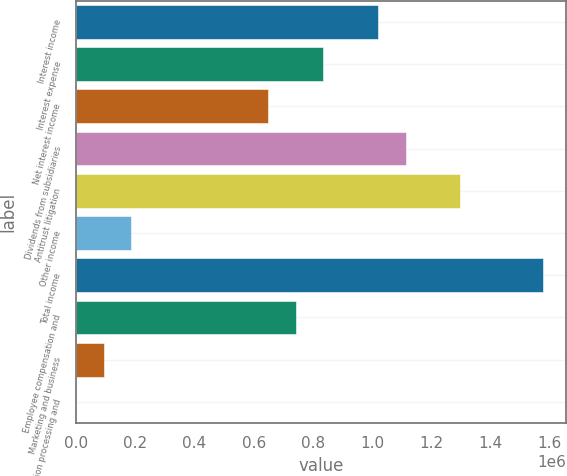Convert chart to OTSL. <chart><loc_0><loc_0><loc_500><loc_500><bar_chart><fcel>Interest income<fcel>Interest expense<fcel>Net interest income<fcel>Dividends from subsidiaries<fcel>Antitrust litigation<fcel>Other income<fcel>Total income<fcel>Employee compensation and<fcel>Marketing and business<fcel>Information processing and<nl><fcel>1.02051e+06<fcel>834987<fcel>649462<fcel>1.11328e+06<fcel>1.2988e+06<fcel>185648<fcel>1.57709e+06<fcel>742225<fcel>92885.7<fcel>123<nl></chart> 